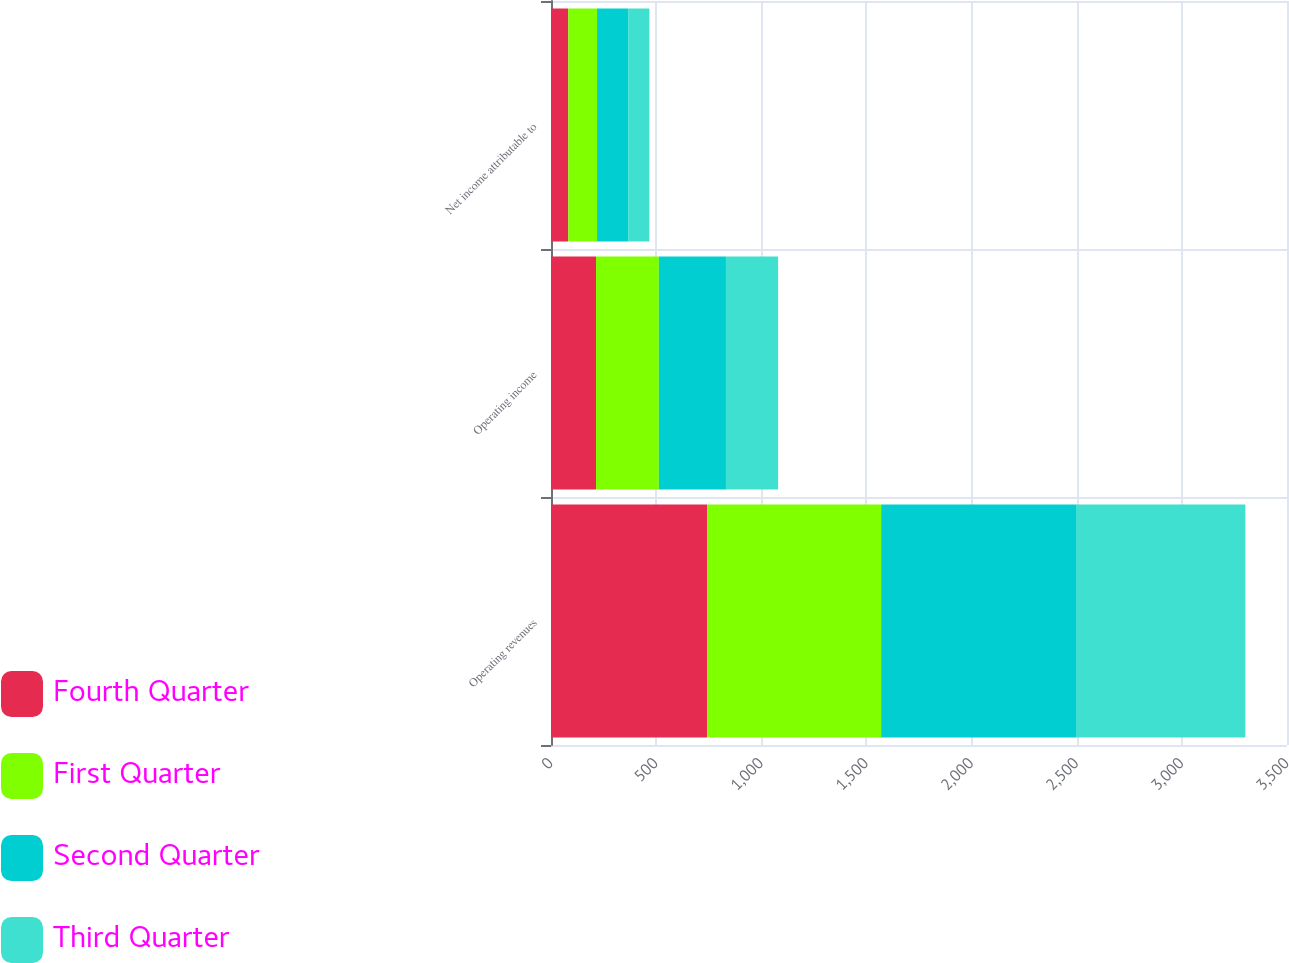<chart> <loc_0><loc_0><loc_500><loc_500><stacked_bar_chart><ecel><fcel>Operating revenues<fcel>Operating income<fcel>Net income attributable to<nl><fcel>Fourth Quarter<fcel>743<fcel>214<fcel>82<nl><fcel>First Quarter<fcel>827<fcel>299<fcel>137<nl><fcel>Second Quarter<fcel>930<fcel>319<fcel>148<nl><fcel>Third Quarter<fcel>802<fcel>248<fcel>101<nl></chart> 